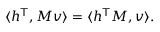Convert formula to latex. <formula><loc_0><loc_0><loc_500><loc_500>\langle h ^ { T } , M v \rangle = \langle h ^ { T } M , v \rangle .</formula> 